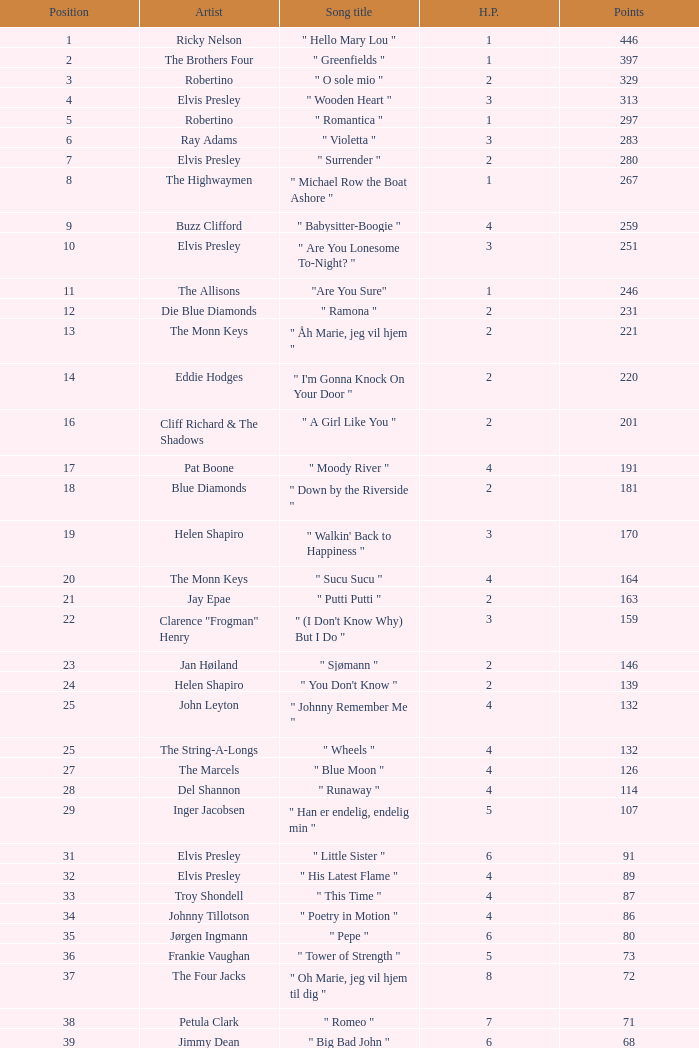What is highest place reached by artist Ray Adams? 6.0. 